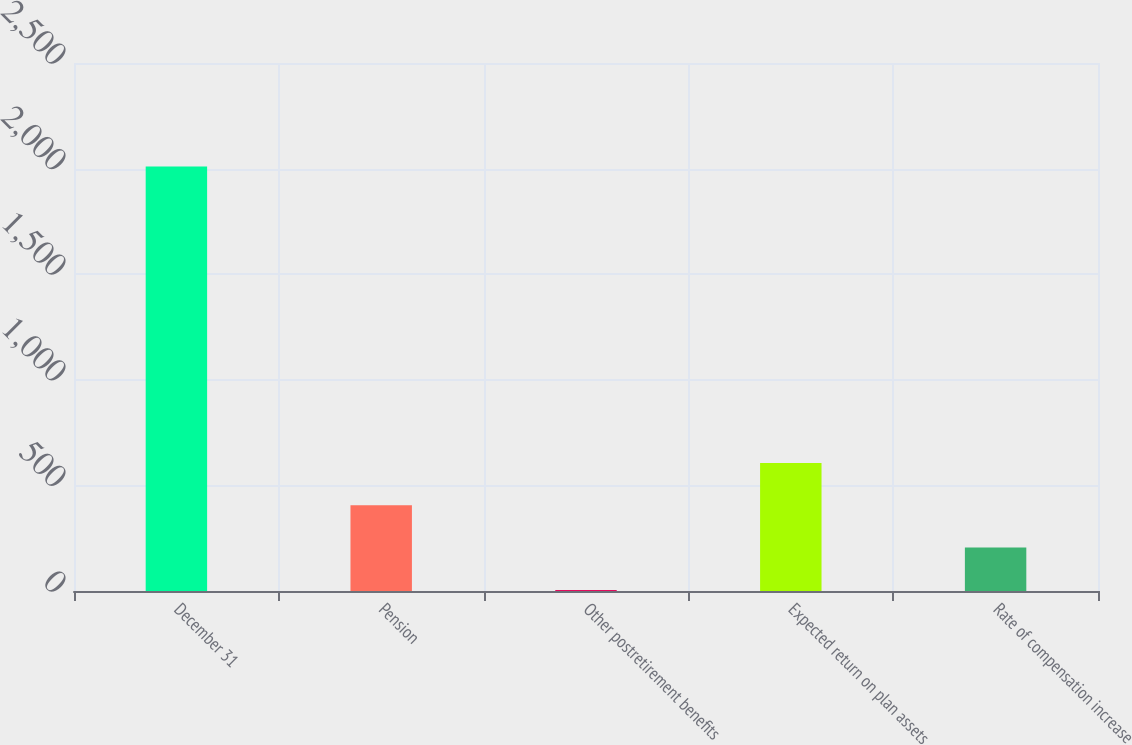Convert chart. <chart><loc_0><loc_0><loc_500><loc_500><bar_chart><fcel>December 31<fcel>Pension<fcel>Other postretirement benefits<fcel>Expected return on plan assets<fcel>Rate of compensation increase<nl><fcel>2010<fcel>405.92<fcel>4.9<fcel>606.43<fcel>205.41<nl></chart> 